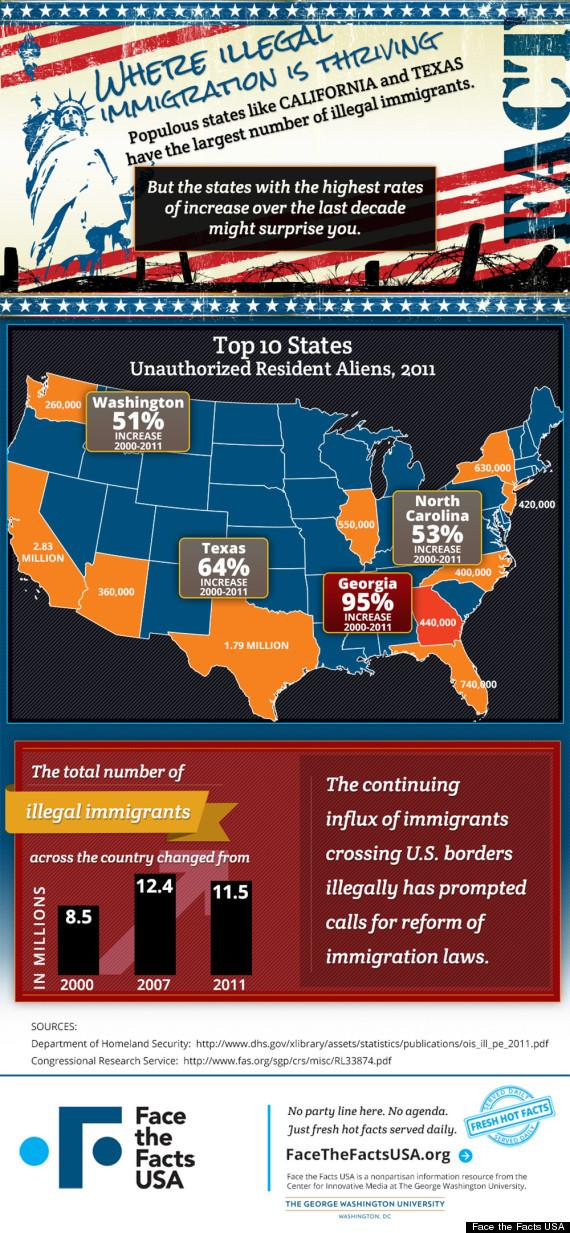Highlight a few significant elements in this photo. The percentage increase in unauthorized resident aliens in Texas from 2000 to 2011 was 64%. 